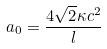Convert formula to latex. <formula><loc_0><loc_0><loc_500><loc_500>a _ { 0 } = \frac { 4 \sqrt { 2 } \kappa c ^ { 2 } } { l }</formula> 